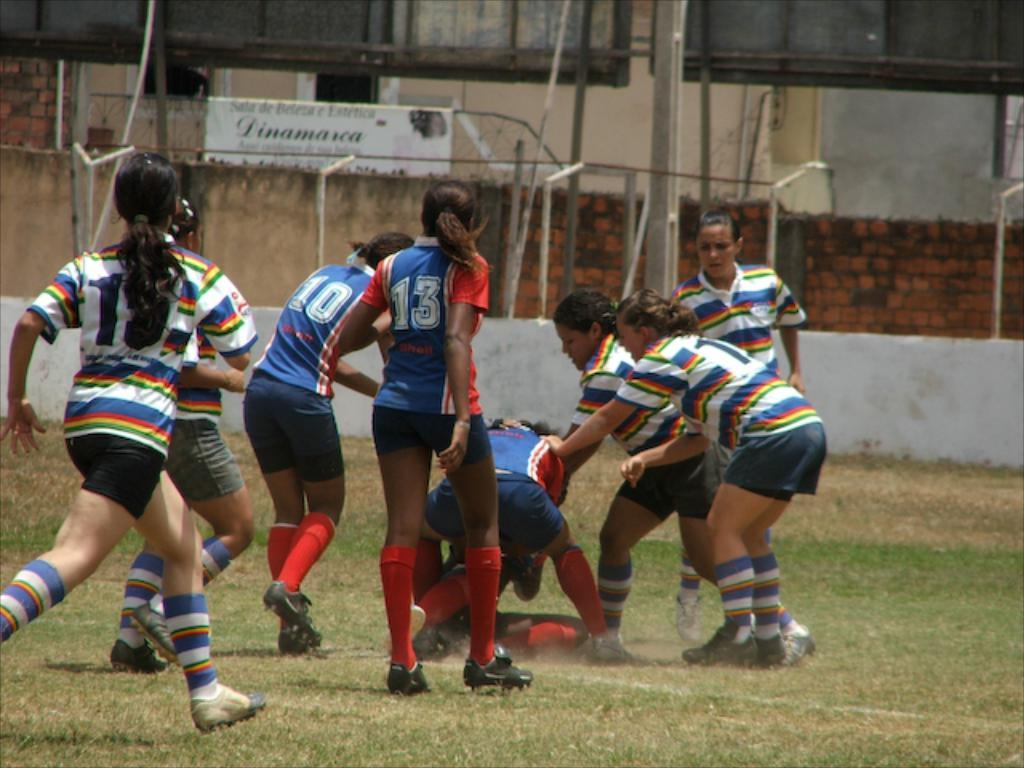Who or what can be seen in the image? There are people in the image. What type of natural environment is visible in the image? There is grass visible in the image. What architectural features can be seen in the background of the image? There are boards, poles, walls, and windows in the background of the image. What decision was made during the fight in the image? There is no fight or decision-making process depicted in the image. 